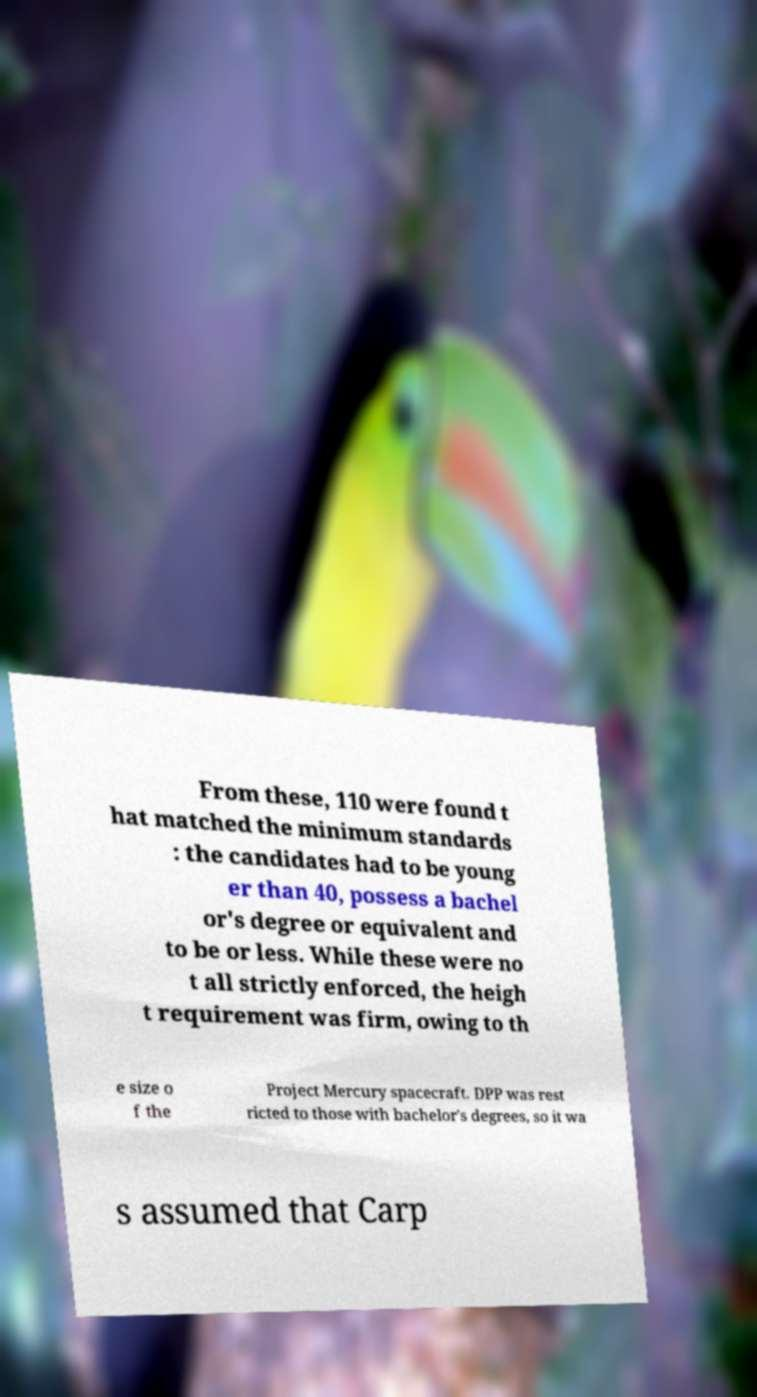Could you extract and type out the text from this image? From these, 110 were found t hat matched the minimum standards : the candidates had to be young er than 40, possess a bachel or's degree or equivalent and to be or less. While these were no t all strictly enforced, the heigh t requirement was firm, owing to th e size o f the Project Mercury spacecraft. DPP was rest ricted to those with bachelor's degrees, so it wa s assumed that Carp 